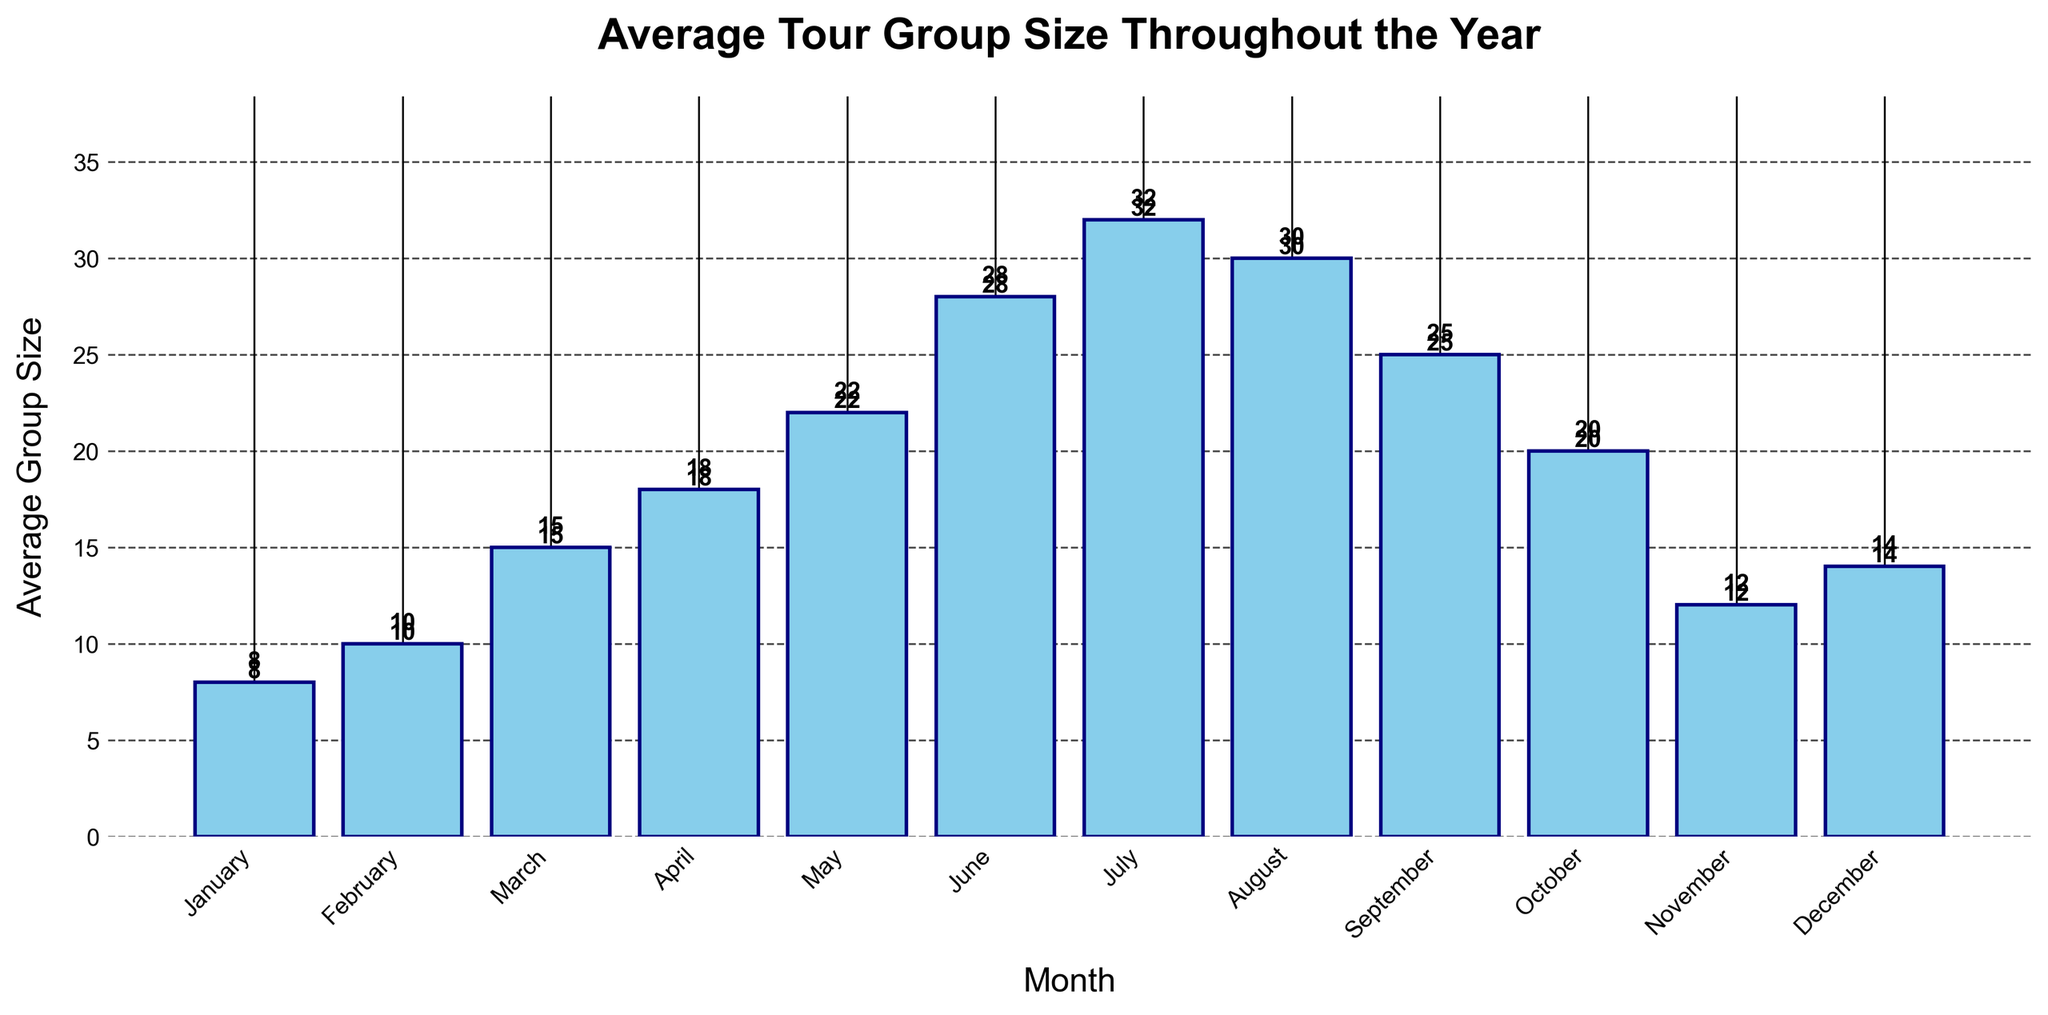What is the average tour group size in July? Look at the bar corresponding to July and note the height of the bar, which represents the average group size for that month.
Answer: 32 Which month has the smallest average tour group size? Identify the shortest bar in the chart, which represents the month with the smallest average group size.
Answer: January How does the average group size in April compare to that in October? Find the heights of the bars for April and October. April's bar is 18 units high, and October's is 20 units high, so October is slightly higher.
Answer: October is greater What is the total sum of the average group sizes from January to March? Sum the heights of the bars for January (8), February (10), and March (15). 8 + 10 + 15 = 33.
Answer: 33 What is the difference in average group size between June and December? Subtract the height of the December bar (14) from the height of the June bar (28). 28 - 14 = 14.
Answer: 14 Which months have an average tour group size greater than 20? Identify the months where the bars are taller than the 20-unit mark. May, June, July, August, and September have group sizes greater than 20.
Answer: May, June, July, August, September What is the percentage increase in average group size from November to December? Calculate the difference between December (14) and November (12), divide by November's value, then multiply by 100. (14 - 12) / 12 * 100 = 16.67%.
Answer: 16.67% How many months have an average tour group size less than or equal to 15? Count the bars with heights less than or equal to 15. The months are January, February, March, November, and December. There are 5 such months.
Answer: 5 By how much does the average group size in August exceed that in February? Subtract the height of the February bar (10) from the height of the August bar (30). 30 - 10 = 20.
Answer: 20 What is the range of the average tour group sizes throughout the year? Identify the maximum and minimum bar heights. The maximum is July (32) and the minimum is January (8). Subtract the minimum from the maximum. 32 - 8 = 24.
Answer: 24 